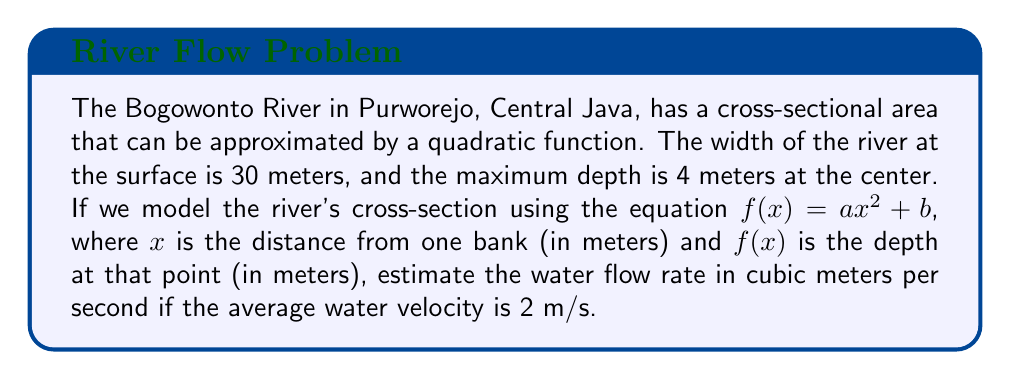Solve this math problem. To solve this problem, we'll follow these steps:

1. Find the quadratic function that models the river's cross-section:
   - We know that $f(0) = f(30) = 0$ (depth at the banks)
   - The maximum depth is 4 meters at $x = 15$ (center of the river)

   Let's use the vertex form of a quadratic equation: $f(x) = -a(x-h)^2 + k$
   Where $(h,k)$ is the vertex (15, 4)

   $f(x) = -a(x-15)^2 + 4$

   Using the point (0,0):
   $0 = -a(0-15)^2 + 4$
   $0 = -225a + 4$
   $a = \frac{4}{225} = \frac{4}{15^2}$

   So, our quadratic function is: $f(x) = -\frac{4}{225}(x-15)^2 + 4$

2. Calculate the area of the cross-section:
   The area is given by the integral of $f(x)$ from 0 to 30:

   $$A = \int_0^{30} (-\frac{4}{225}(x-15)^2 + 4) dx$$

   $$A = [-\frac{4}{675}(x-15)^3 + 4x]_0^{30}$$

   $$A = [-\frac{4}{675}(15)^3 + 120] - [-\frac{4}{675}(-15)^3 + 0]$$

   $$A = [-60 + 120] - [60] = 60 \text{ m}^2$$

3. Calculate the flow rate:
   Flow rate = Cross-sectional area × Average velocity
   $$Q = A \times v = 60 \text{ m}^2 \times 2 \text{ m/s} = 120 \text{ m}^3/\text{s}$$

Therefore, the estimated water flow rate in the Bogowonto River is 120 cubic meters per second.
Answer: 120 m³/s 